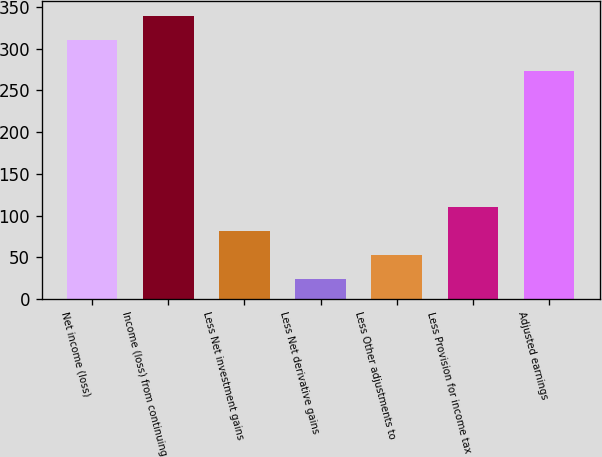Convert chart. <chart><loc_0><loc_0><loc_500><loc_500><bar_chart><fcel>Net income (loss)<fcel>Income (loss) from continuing<fcel>Less Net investment gains<fcel>Less Net derivative gains<fcel>Less Other adjustments to<fcel>Less Provision for income tax<fcel>Adjusted earnings<nl><fcel>311<fcel>339.7<fcel>81.4<fcel>24<fcel>52.7<fcel>110.1<fcel>273<nl></chart> 